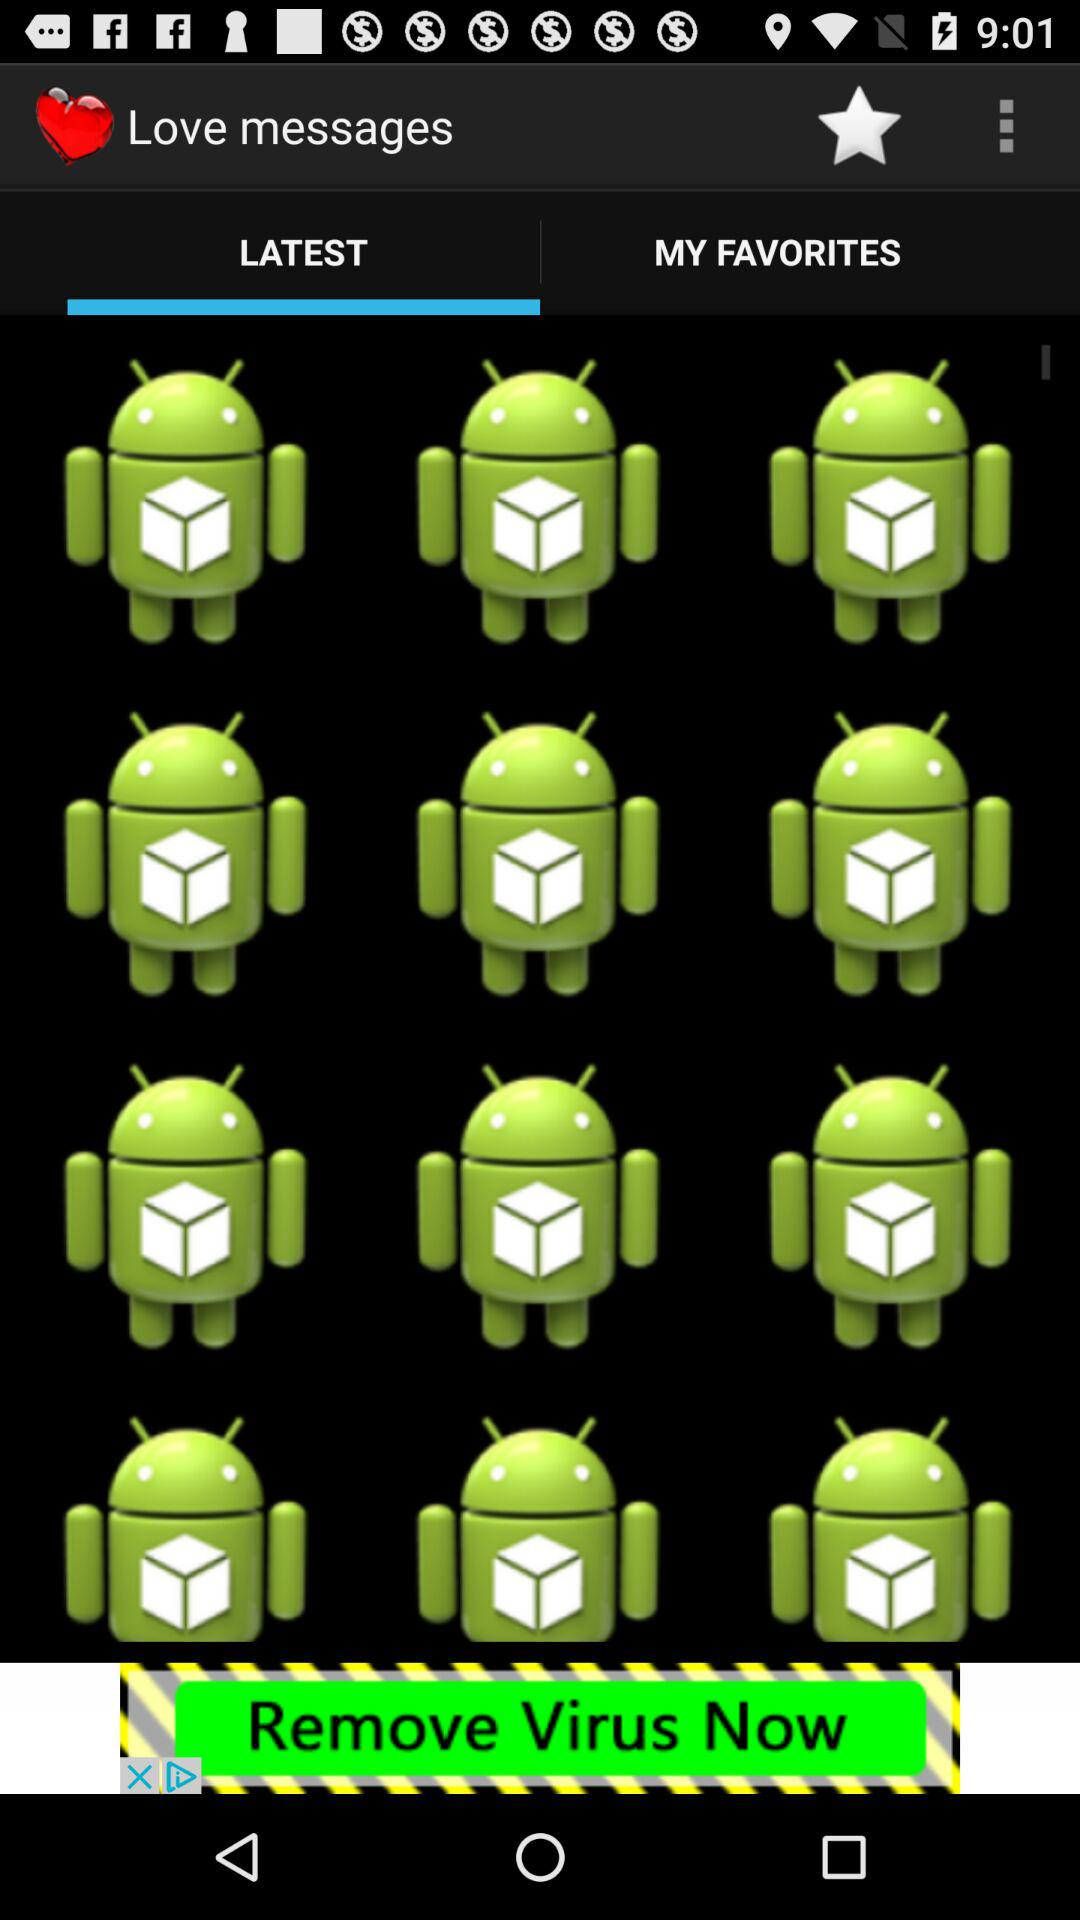What is the application name? The application name is "Love messages". 